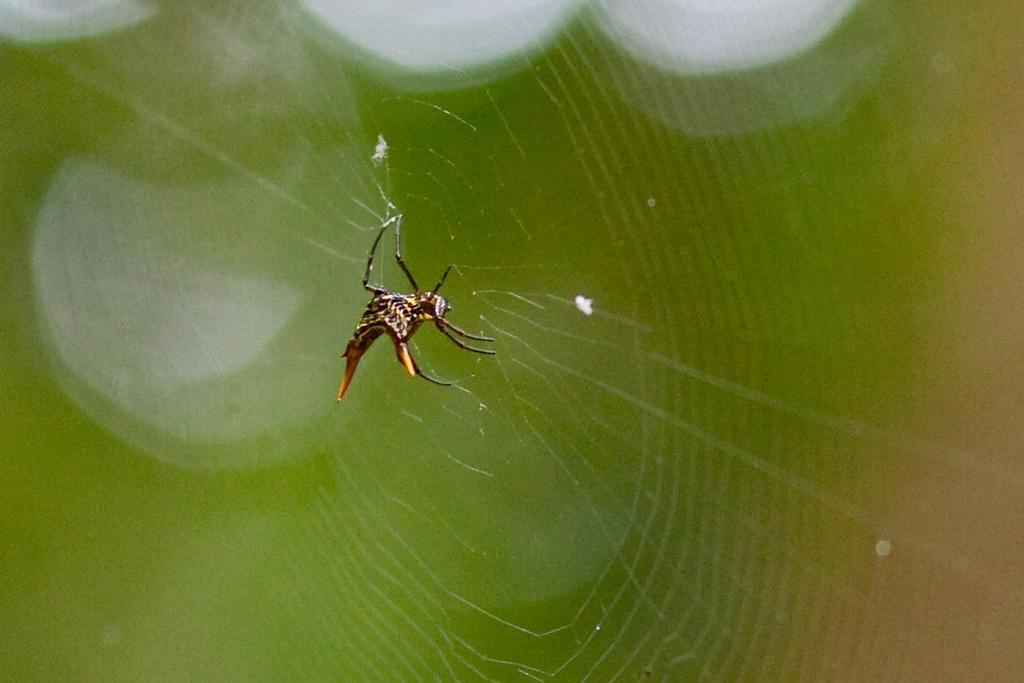What is the main subject of the image? There is a spider in the image. Where is the spider located? The spider is in a spider web. Can you describe the background of the image? The background of the image is blurry. What letter does the baby start to learn in the image? There is no baby or letter present in the image; it features a spider in a spider web with a blurry background. 